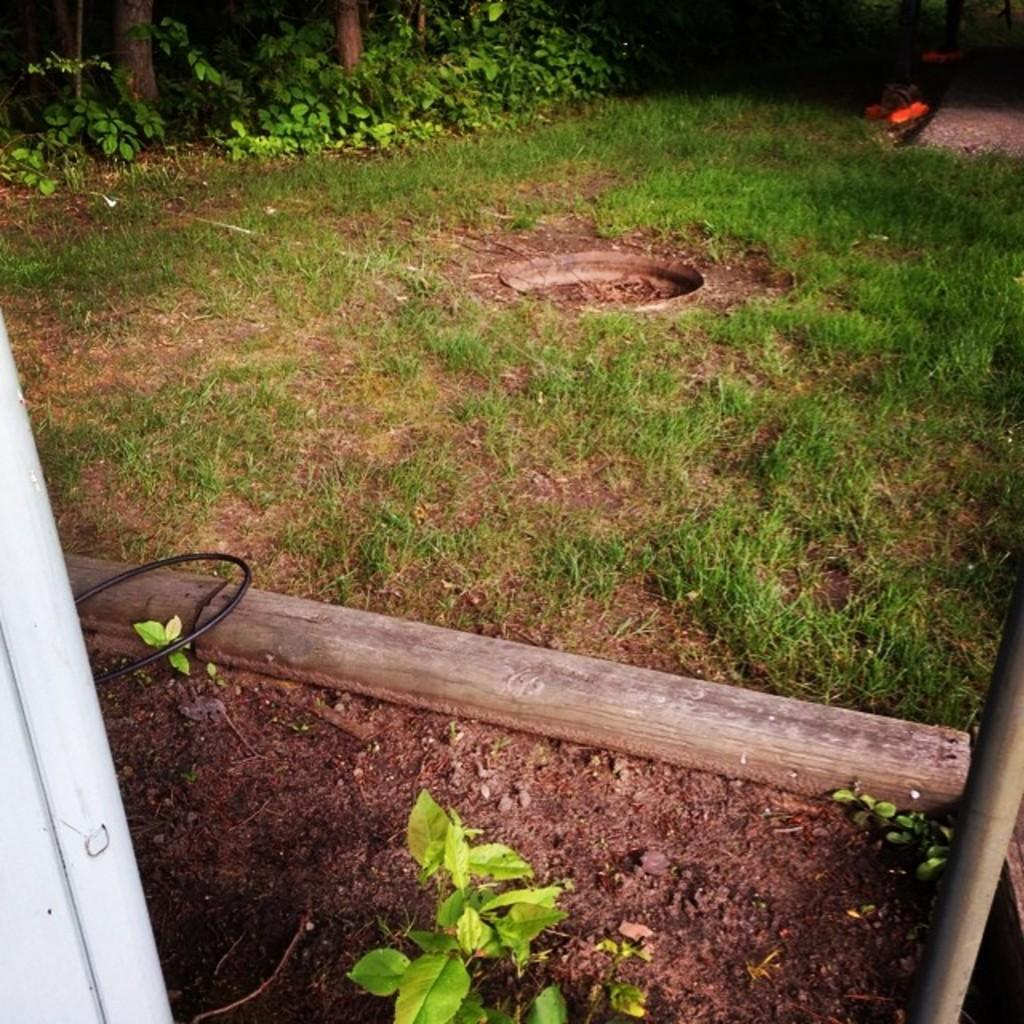What type of natural elements can be seen in the image? There are logs, plants, and trees in the image. What else is present in the image besides natural elements? There are objects and a wall in the image. What is the surface on which the objects and natural elements are situated? There is a ground at the bottom of the image. What type of ticket is visible on the canvas in the image? There is no ticket or canvas present in the image. What kind of nut is being used as a decoration in the image? There is no nut being used as a decoration in the image. 